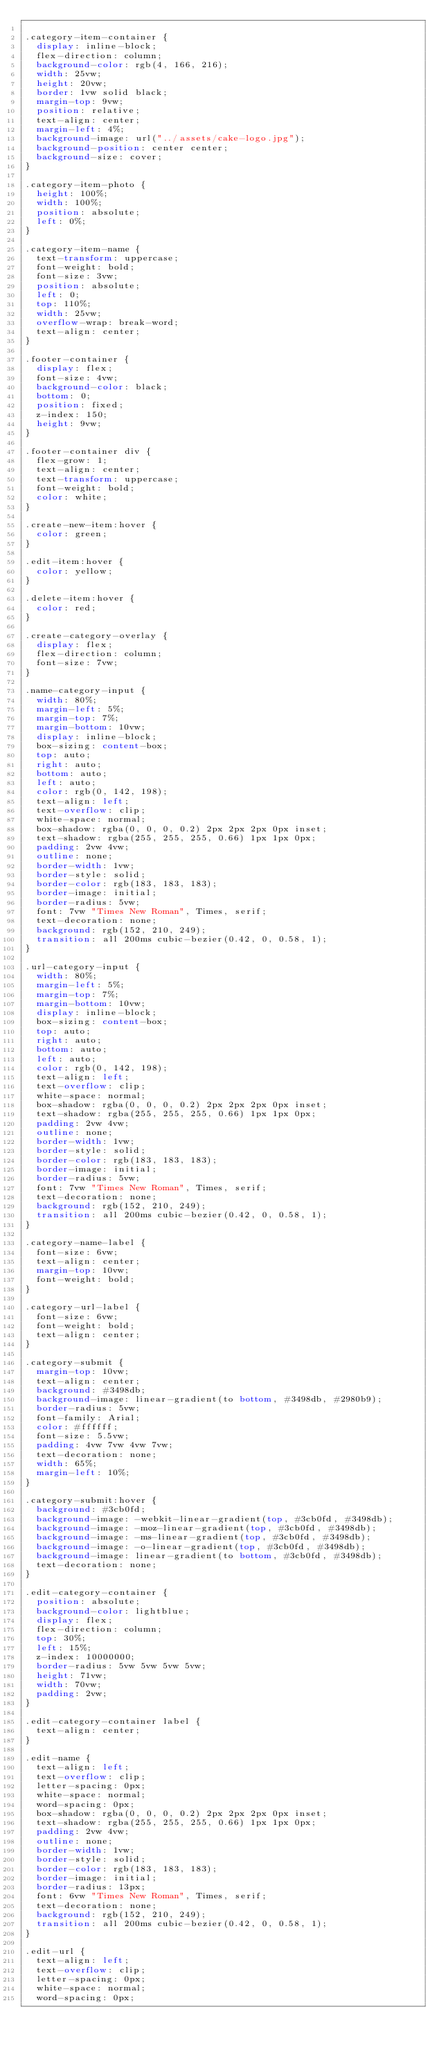<code> <loc_0><loc_0><loc_500><loc_500><_CSS_>
.category-item-container {
  display: inline-block;
  flex-direction: column;
  background-color: rgb(4, 166, 216);
  width: 25vw;
  height: 20vw;
  border: 1vw solid black;
  margin-top: 9vw;
  position: relative;
  text-align: center;
  margin-left: 4%;
  background-image: url("../assets/cake-logo.jpg");
  background-position: center center;
  background-size: cover;
}

.category-item-photo {
  height: 100%;
  width: 100%;
  position: absolute;
  left: 0%;
}

.category-item-name {
  text-transform: uppercase;
  font-weight: bold;
  font-size: 3vw;
  position: absolute;
  left: 0;
  top: 110%;
  width: 25vw;
  overflow-wrap: break-word;
  text-align: center;
}

.footer-container {
  display: flex;
  font-size: 4vw;
  background-color: black;
  bottom: 0;
  position: fixed;
  z-index: 150;
  height: 9vw;
}

.footer-container div {
  flex-grow: 1;
  text-align: center;
  text-transform: uppercase;
  font-weight: bold;
  color: white;
}

.create-new-item:hover {
  color: green;
}

.edit-item:hover {
  color: yellow;
}

.delete-item:hover {
  color: red;
}

.create-category-overlay {
  display: flex;
  flex-direction: column;
  font-size: 7vw;
}

.name-category-input {
  width: 80%;
  margin-left: 5%;
  margin-top: 7%;
  margin-bottom: 10vw;
  display: inline-block;
  box-sizing: content-box;
  top: auto;
  right: auto;
  bottom: auto;
  left: auto;
  color: rgb(0, 142, 198);
  text-align: left;
  text-overflow: clip;
  white-space: normal;
  box-shadow: rgba(0, 0, 0, 0.2) 2px 2px 2px 0px inset;
  text-shadow: rgba(255, 255, 255, 0.66) 1px 1px 0px;
  padding: 2vw 4vw;
  outline: none;
  border-width: 1vw;
  border-style: solid;
  border-color: rgb(183, 183, 183);
  border-image: initial;
  border-radius: 5vw;
  font: 7vw "Times New Roman", Times, serif;
  text-decoration: none;
  background: rgb(152, 210, 249);
  transition: all 200ms cubic-bezier(0.42, 0, 0.58, 1);
}

.url-category-input {
  width: 80%;
  margin-left: 5%;
  margin-top: 7%;
  margin-bottom: 10vw;
  display: inline-block;
  box-sizing: content-box;
  top: auto;
  right: auto;
  bottom: auto;
  left: auto;
  color: rgb(0, 142, 198);
  text-align: left;
  text-overflow: clip;
  white-space: normal;
  box-shadow: rgba(0, 0, 0, 0.2) 2px 2px 2px 0px inset;
  text-shadow: rgba(255, 255, 255, 0.66) 1px 1px 0px;
  padding: 2vw 4vw;
  outline: none;
  border-width: 1vw;
  border-style: solid;
  border-color: rgb(183, 183, 183);
  border-image: initial;
  border-radius: 5vw;
  font: 7vw "Times New Roman", Times, serif;
  text-decoration: none;
  background: rgb(152, 210, 249);
  transition: all 200ms cubic-bezier(0.42, 0, 0.58, 1);
}

.category-name-label {
  font-size: 6vw;
  text-align: center;
  margin-top: 10vw;
  font-weight: bold;
}

.category-url-label {
  font-size: 6vw;
  font-weight: bold;
  text-align: center;
}

.category-submit {
  margin-top: 10vw;
  text-align: center;
  background: #3498db;
  background-image: linear-gradient(to bottom, #3498db, #2980b9);
  border-radius: 5vw;
  font-family: Arial;
  color: #ffffff;
  font-size: 5.5vw;
  padding: 4vw 7vw 4vw 7vw;
  text-decoration: none;
  width: 65%;
  margin-left: 10%;
}

.category-submit:hover {
  background: #3cb0fd;
  background-image: -webkit-linear-gradient(top, #3cb0fd, #3498db);
  background-image: -moz-linear-gradient(top, #3cb0fd, #3498db);
  background-image: -ms-linear-gradient(top, #3cb0fd, #3498db);
  background-image: -o-linear-gradient(top, #3cb0fd, #3498db);
  background-image: linear-gradient(to bottom, #3cb0fd, #3498db);
  text-decoration: none;
}

.edit-category-container {
  position: absolute;
  background-color: lightblue;
  display: flex;
  flex-direction: column;
  top: 30%;
  left: 15%;
  z-index: 10000000;
  border-radius: 5vw 5vw 5vw 5vw;
  height: 71vw;
  width: 70vw;
  padding: 2vw;
}

.edit-category-container label {
  text-align: center;
}

.edit-name {
  text-align: left;
  text-overflow: clip;
  letter-spacing: 0px;
  white-space: normal;
  word-spacing: 0px;
  box-shadow: rgba(0, 0, 0, 0.2) 2px 2px 2px 0px inset;
  text-shadow: rgba(255, 255, 255, 0.66) 1px 1px 0px;
  padding: 2vw 4vw;
  outline: none;
  border-width: 1vw;
  border-style: solid;
  border-color: rgb(183, 183, 183);
  border-image: initial;
  border-radius: 13px;
  font: 6vw "Times New Roman", Times, serif;
  text-decoration: none;
  background: rgb(152, 210, 249);
  transition: all 200ms cubic-bezier(0.42, 0, 0.58, 1);
}

.edit-url {
  text-align: left;
  text-overflow: clip;
  letter-spacing: 0px;
  white-space: normal;
  word-spacing: 0px;</code> 